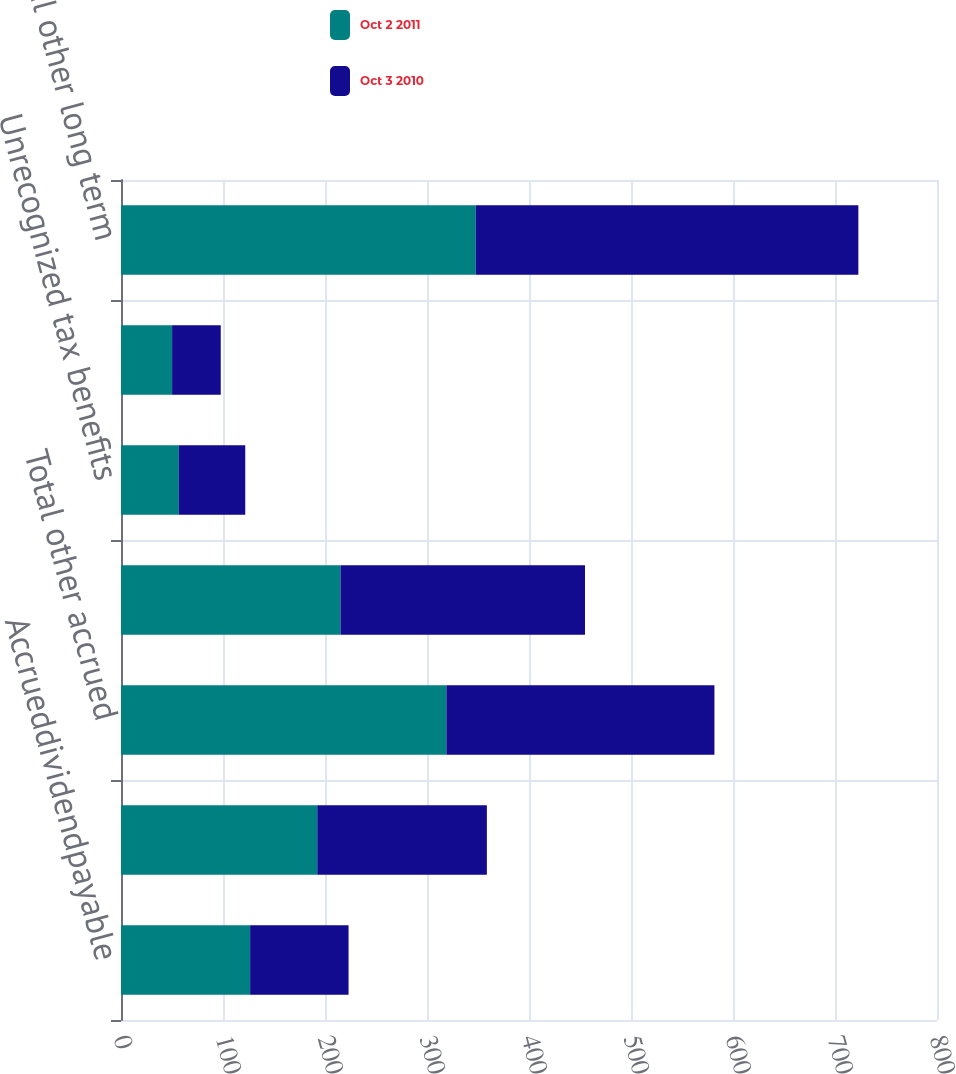Convert chart. <chart><loc_0><loc_0><loc_500><loc_500><stacked_bar_chart><ecel><fcel>Accrueddividendpayable<fcel>Other<fcel>Total other accrued<fcel>Deferredrent<fcel>Unrecognized tax benefits<fcel>Asset retirement obligations<fcel>Total other long term<nl><fcel>Oct 2 2011<fcel>126.6<fcel>192.4<fcel>319<fcel>215.2<fcel>56.7<fcel>50.1<fcel>347.8<nl><fcel>Oct 3 2010<fcel>96.5<fcel>166.3<fcel>262.8<fcel>239.7<fcel>65.1<fcel>47.7<fcel>375.1<nl></chart> 